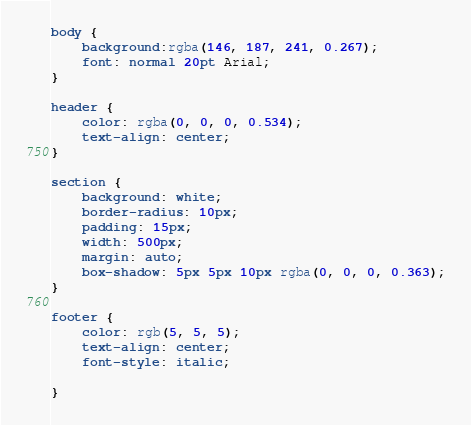<code> <loc_0><loc_0><loc_500><loc_500><_CSS_>body {
    background:rgba(146, 187, 241, 0.267);
    font: normal 20pt Arial;
}

header {
    color: rgba(0, 0, 0, 0.534);
    text-align: center;
}

section {
    background: white;
    border-radius: 10px;
    padding: 15px;
    width: 500px;
    margin: auto;
    box-shadow: 5px 5px 10px rgba(0, 0, 0, 0.363);
}

footer {
    color: rgb(5, 5, 5);
    text-align: center;
    font-style: italic;

}
</code> 